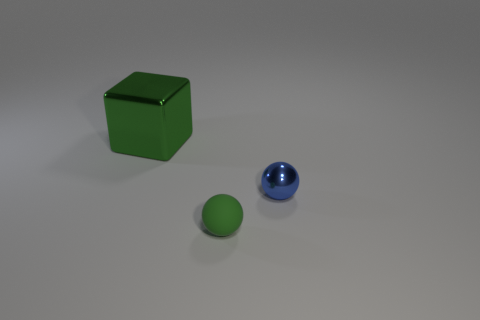Do the tiny rubber object and the shiny cube have the same color?
Provide a succinct answer. Yes. What number of big shiny objects are the same color as the rubber ball?
Provide a short and direct response. 1. Are there any other things that have the same material as the tiny green ball?
Provide a succinct answer. No. The thing that is on the left side of the metallic sphere and right of the big green shiny object is what color?
Provide a short and direct response. Green. Do the blue thing and the green thing behind the green rubber thing have the same material?
Provide a succinct answer. Yes. Are there fewer small metal things that are behind the block than large brown cylinders?
Provide a succinct answer. No. How many other objects are the same shape as the big object?
Give a very brief answer. 0. Is there any other thing of the same color as the large thing?
Your answer should be compact. Yes. There is a large shiny cube; is its color the same as the tiny object in front of the blue metallic thing?
Make the answer very short. Yes. What number of other objects are there of the same size as the green metallic cube?
Your response must be concise. 0. 